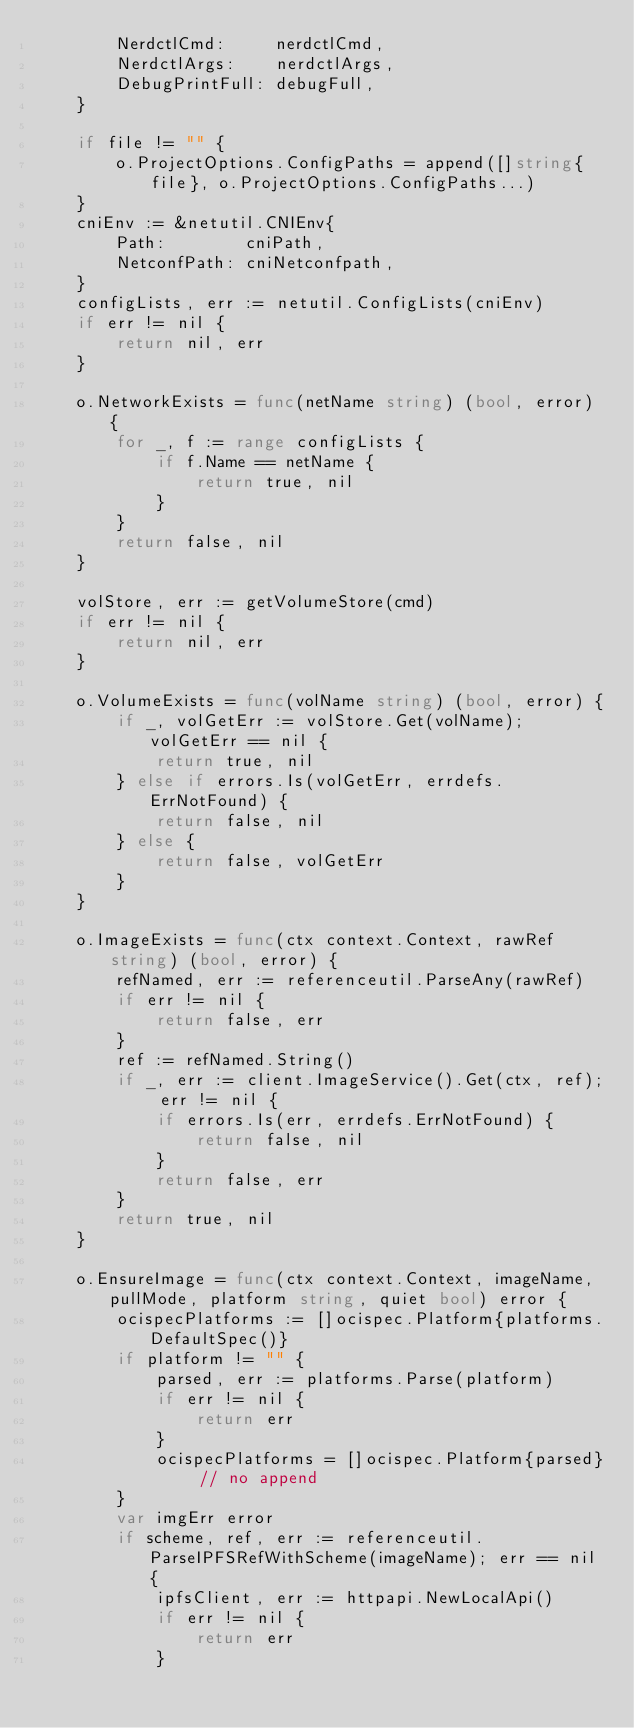<code> <loc_0><loc_0><loc_500><loc_500><_Go_>		NerdctlCmd:     nerdctlCmd,
		NerdctlArgs:    nerdctlArgs,
		DebugPrintFull: debugFull,
	}

	if file != "" {
		o.ProjectOptions.ConfigPaths = append([]string{file}, o.ProjectOptions.ConfigPaths...)
	}
	cniEnv := &netutil.CNIEnv{
		Path:        cniPath,
		NetconfPath: cniNetconfpath,
	}
	configLists, err := netutil.ConfigLists(cniEnv)
	if err != nil {
		return nil, err
	}

	o.NetworkExists = func(netName string) (bool, error) {
		for _, f := range configLists {
			if f.Name == netName {
				return true, nil
			}
		}
		return false, nil
	}

	volStore, err := getVolumeStore(cmd)
	if err != nil {
		return nil, err
	}

	o.VolumeExists = func(volName string) (bool, error) {
		if _, volGetErr := volStore.Get(volName); volGetErr == nil {
			return true, nil
		} else if errors.Is(volGetErr, errdefs.ErrNotFound) {
			return false, nil
		} else {
			return false, volGetErr
		}
	}

	o.ImageExists = func(ctx context.Context, rawRef string) (bool, error) {
		refNamed, err := referenceutil.ParseAny(rawRef)
		if err != nil {
			return false, err
		}
		ref := refNamed.String()
		if _, err := client.ImageService().Get(ctx, ref); err != nil {
			if errors.Is(err, errdefs.ErrNotFound) {
				return false, nil
			}
			return false, err
		}
		return true, nil
	}

	o.EnsureImage = func(ctx context.Context, imageName, pullMode, platform string, quiet bool) error {
		ocispecPlatforms := []ocispec.Platform{platforms.DefaultSpec()}
		if platform != "" {
			parsed, err := platforms.Parse(platform)
			if err != nil {
				return err
			}
			ocispecPlatforms = []ocispec.Platform{parsed} // no append
		}
		var imgErr error
		if scheme, ref, err := referenceutil.ParseIPFSRefWithScheme(imageName); err == nil {
			ipfsClient, err := httpapi.NewLocalApi()
			if err != nil {
				return err
			}</code> 